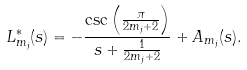Convert formula to latex. <formula><loc_0><loc_0><loc_500><loc_500>L _ { m _ { j } } ^ { * } ( s ) = - \frac { \csc \left ( \frac { \pi } { 2 m _ { j } + 2 } \right ) } { s + \frac { 1 } { 2 m _ { j } + 2 } } + A _ { m _ { j } } ( s ) .</formula> 